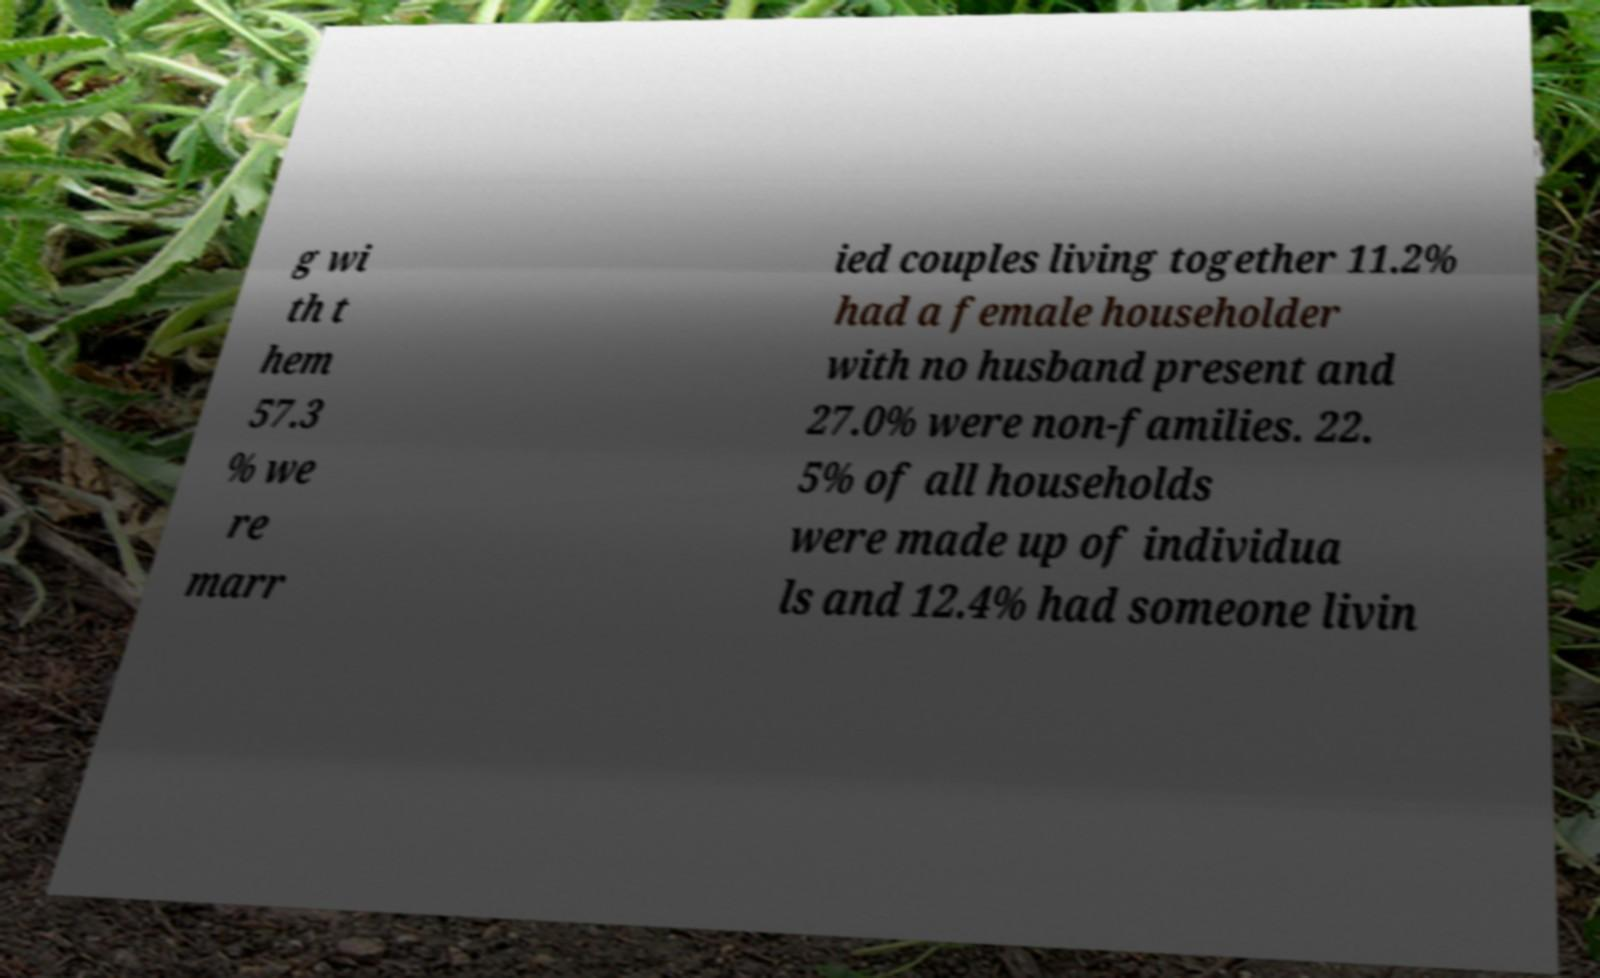For documentation purposes, I need the text within this image transcribed. Could you provide that? g wi th t hem 57.3 % we re marr ied couples living together 11.2% had a female householder with no husband present and 27.0% were non-families. 22. 5% of all households were made up of individua ls and 12.4% had someone livin 